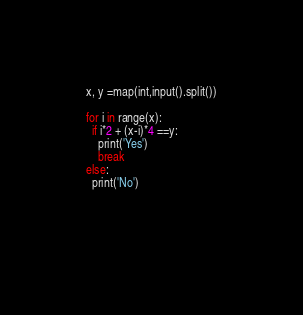<code> <loc_0><loc_0><loc_500><loc_500><_Python_>x, y =map(int,input().split())

for i in range(x):
  if i*2 + (x-i)*4 ==y:
    print('Yes')
    break
else:
  print('No')
          

    </code> 